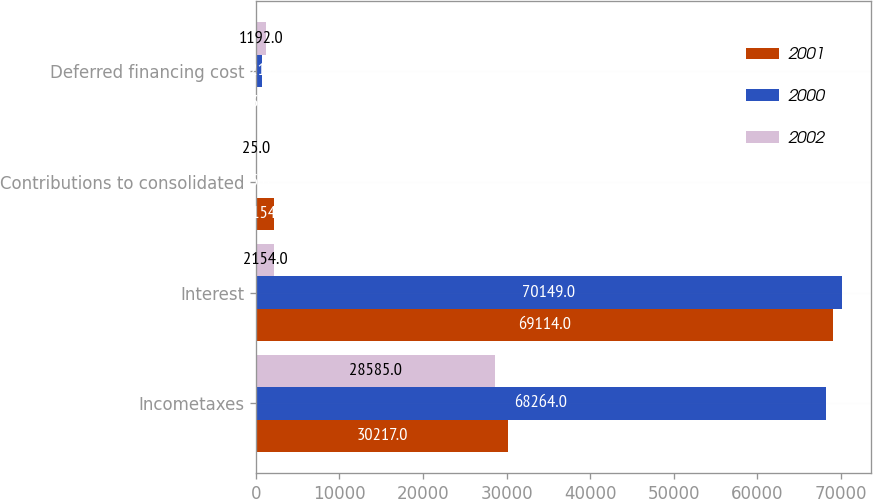Convert chart. <chart><loc_0><loc_0><loc_500><loc_500><stacked_bar_chart><ecel><fcel>Incometaxes<fcel>Interest<fcel>Contributions to consolidated<fcel>Deferred financing cost<nl><fcel>2001<fcel>30217<fcel>69114<fcel>2154<fcel>73<nl><fcel>2000<fcel>68264<fcel>70149<fcel>25<fcel>721<nl><fcel>2002<fcel>28585<fcel>2154<fcel>25<fcel>1192<nl></chart> 